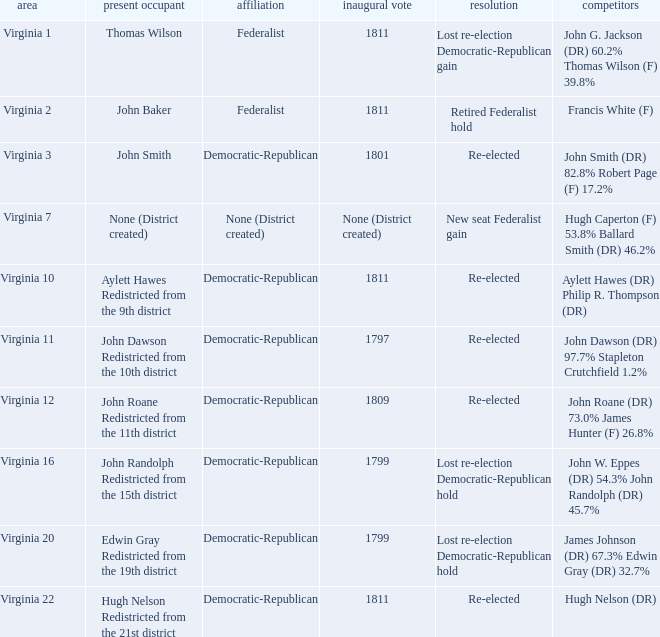Name the party for virginia 12 Democratic-Republican. 